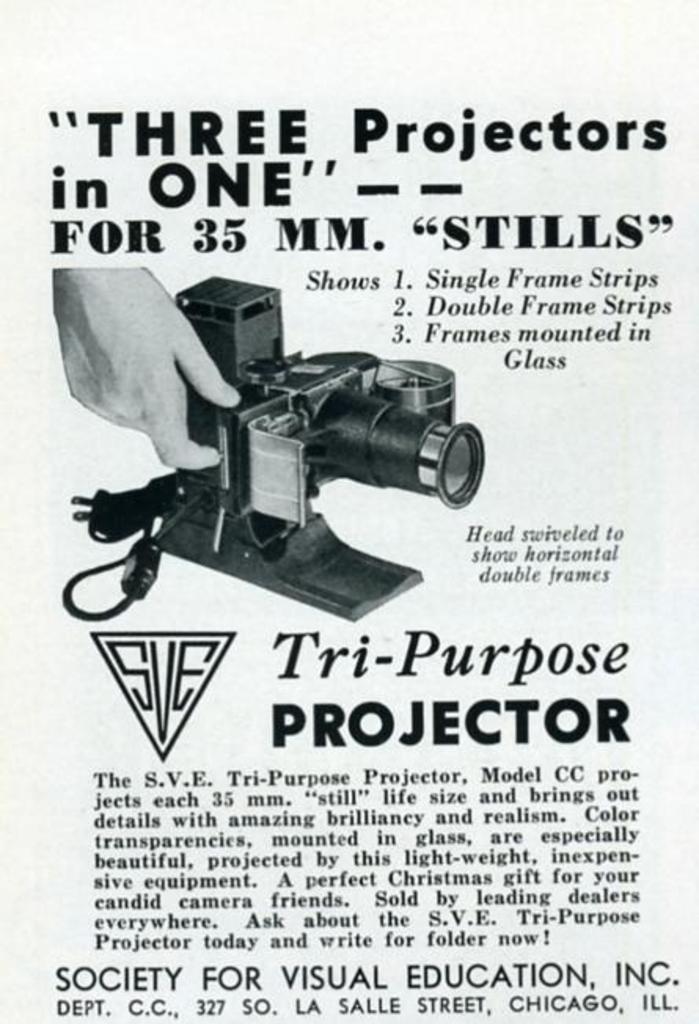How many mm are the stills?
Make the answer very short. 35. 